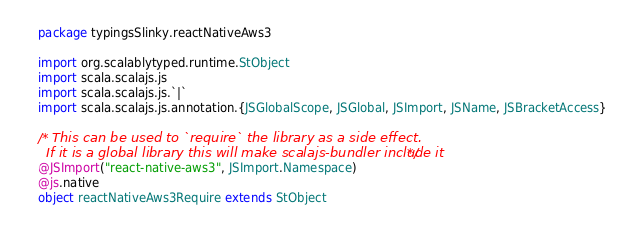Convert code to text. <code><loc_0><loc_0><loc_500><loc_500><_Scala_>package typingsSlinky.reactNativeAws3

import org.scalablytyped.runtime.StObject
import scala.scalajs.js
import scala.scalajs.js.`|`
import scala.scalajs.js.annotation.{JSGlobalScope, JSGlobal, JSImport, JSName, JSBracketAccess}

/* This can be used to `require` the library as a side effect.
  If it is a global library this will make scalajs-bundler include it */
@JSImport("react-native-aws3", JSImport.Namespace)
@js.native
object reactNativeAws3Require extends StObject
</code> 